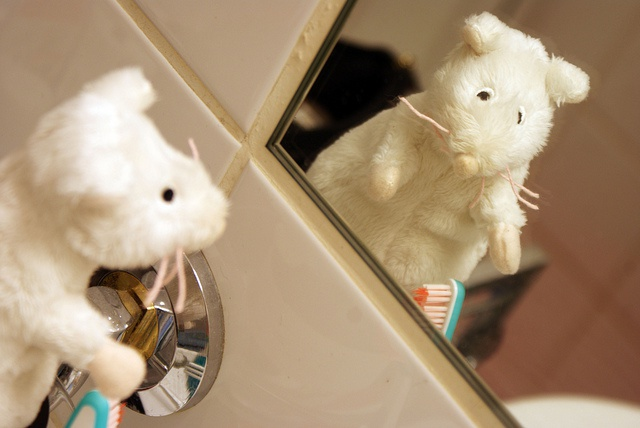Describe the objects in this image and their specific colors. I can see toothbrush in gray, tan, turquoise, and lightgray tones and toothbrush in gray, tan, and turquoise tones in this image. 